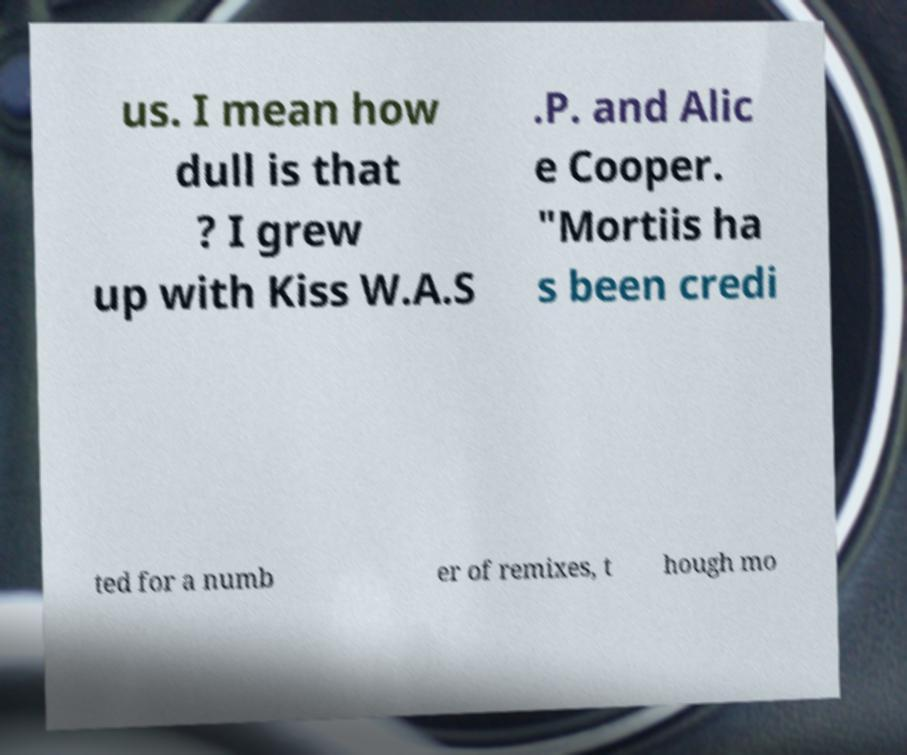I need the written content from this picture converted into text. Can you do that? us. I mean how dull is that ? I grew up with Kiss W.A.S .P. and Alic e Cooper. "Mortiis ha s been credi ted for a numb er of remixes, t hough mo 